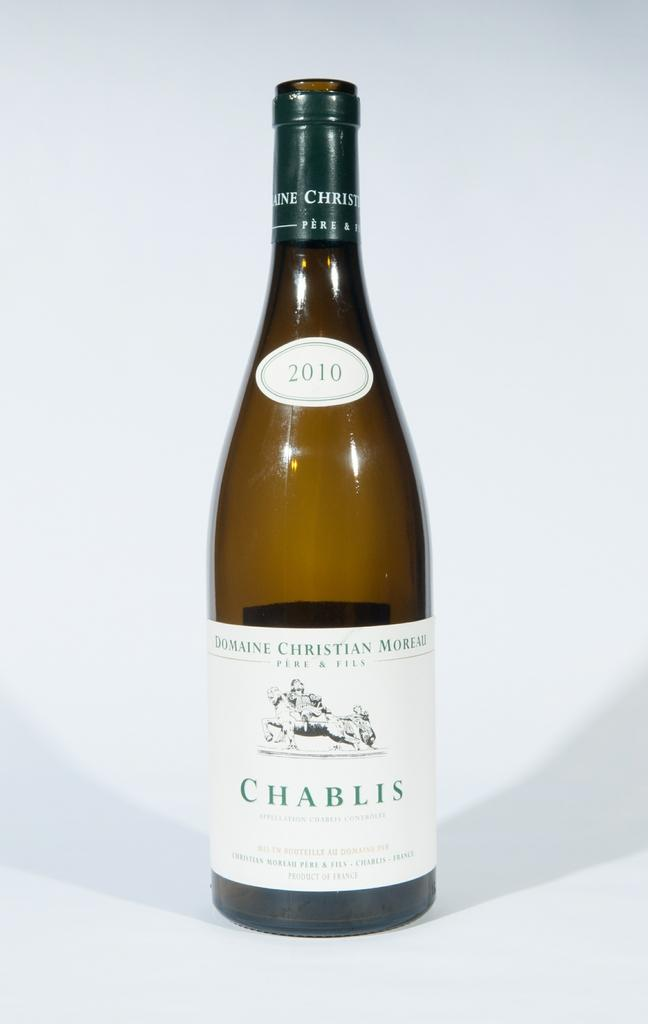What is the main object in the image? There is a liquor bottle in the image. What color is the background of the image? The background of the image is white. How many horses are visible in the image? There are no horses present in the image. Is there a bike leaning against the liquor bottle in the image? There is no bike present in the image. 